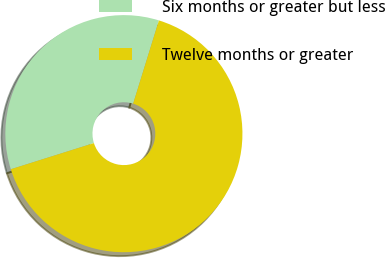Convert chart to OTSL. <chart><loc_0><loc_0><loc_500><loc_500><pie_chart><fcel>Six months or greater but less<fcel>Twelve months or greater<nl><fcel>34.63%<fcel>65.37%<nl></chart> 